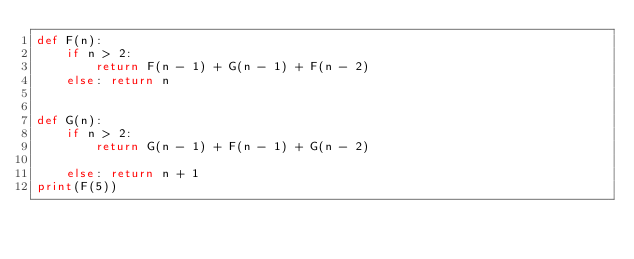<code> <loc_0><loc_0><loc_500><loc_500><_Python_>def F(n):
    if n > 2:
        return F(n - 1) + G(n - 1) + F(n - 2)
    else: return n


def G(n):
    if n > 2:
        return G(n - 1) + F(n - 1) + G(n - 2)

    else: return n + 1
print(F(5))</code> 